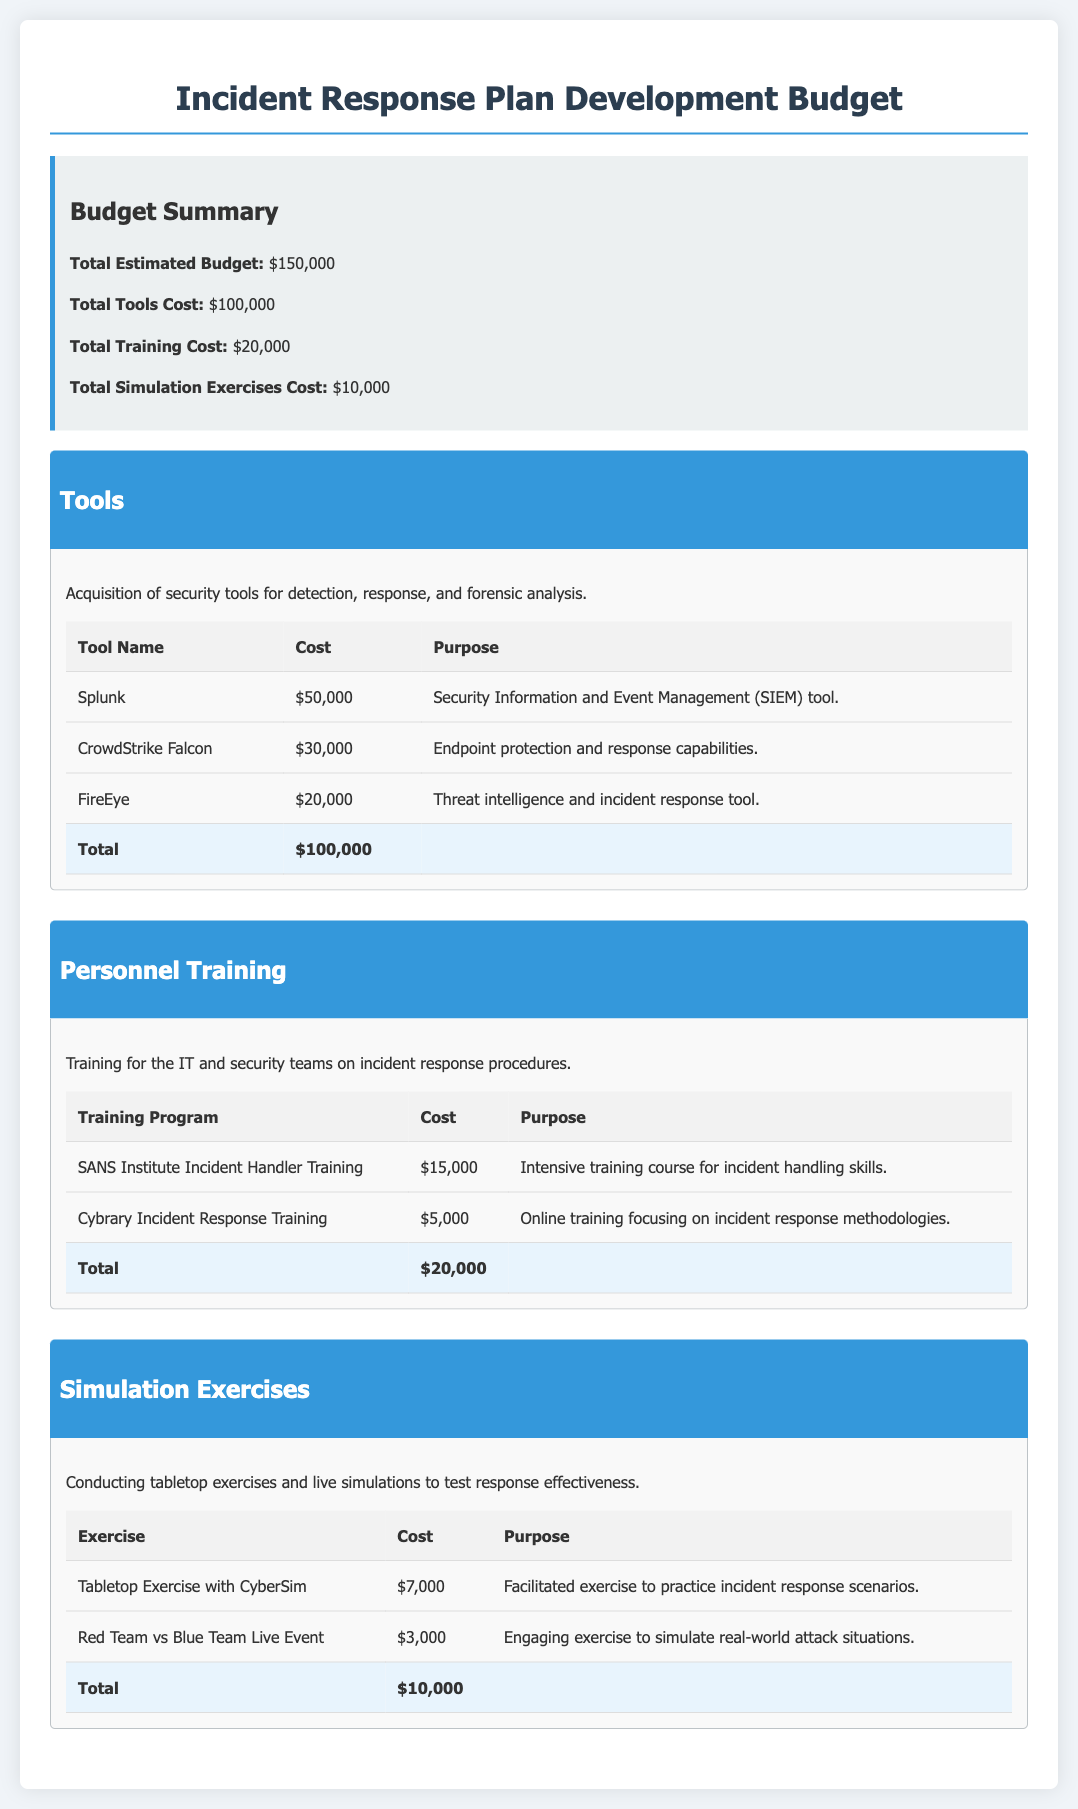What is the total estimated budget? The total estimated budget is summarized in the document as $150,000.
Answer: $150,000 How much is allocated for tools? The document outlines that the total cost for tools is $100,000.
Answer: $100,000 What is the cost of the Splunk tool? The document states that the cost of the Splunk tool is $50,000.
Answer: $50,000 How much is spent on personnel training? According to the document, the total cost for personnel training is $20,000.
Answer: $20,000 What is the purpose of the CrowdStrike Falcon tool? The document specifies that CrowdStrike Falcon provides endpoint protection and response capabilities.
Answer: Endpoint protection and response capabilities How many training programs are listed in the document? The document lists two training programs for personnel training.
Answer: Two What is the total cost for simulation exercises? The document shows that the total cost for simulation exercises is $10,000.
Answer: $10,000 What type of exercise is conducted with CyberSim? The document mentions a tabletop exercise with CyberSim as part of the simulation exercises.
Answer: Tabletop exercise What is the cost of the Red Team vs Blue Team exercise? The cost for the Red Team vs Blue Team live event is stated as $3,000 in the document.
Answer: $3,000 Which organization provides the Incident Handler Training? The document identifies the SANS Institute as the provider of the Incident Handler Training.
Answer: SANS Institute 